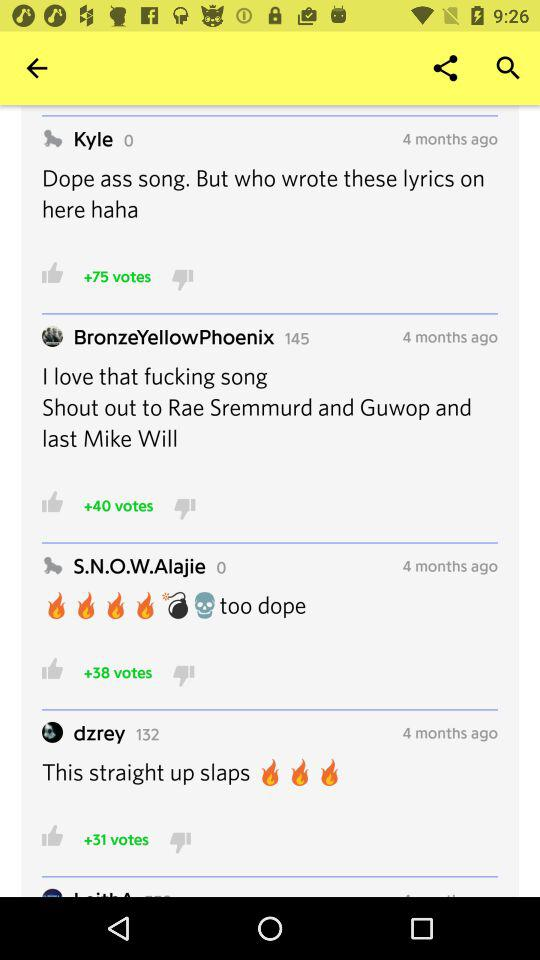What is the comment posted by "dzrey"? The comment is "This straight up slaps". 